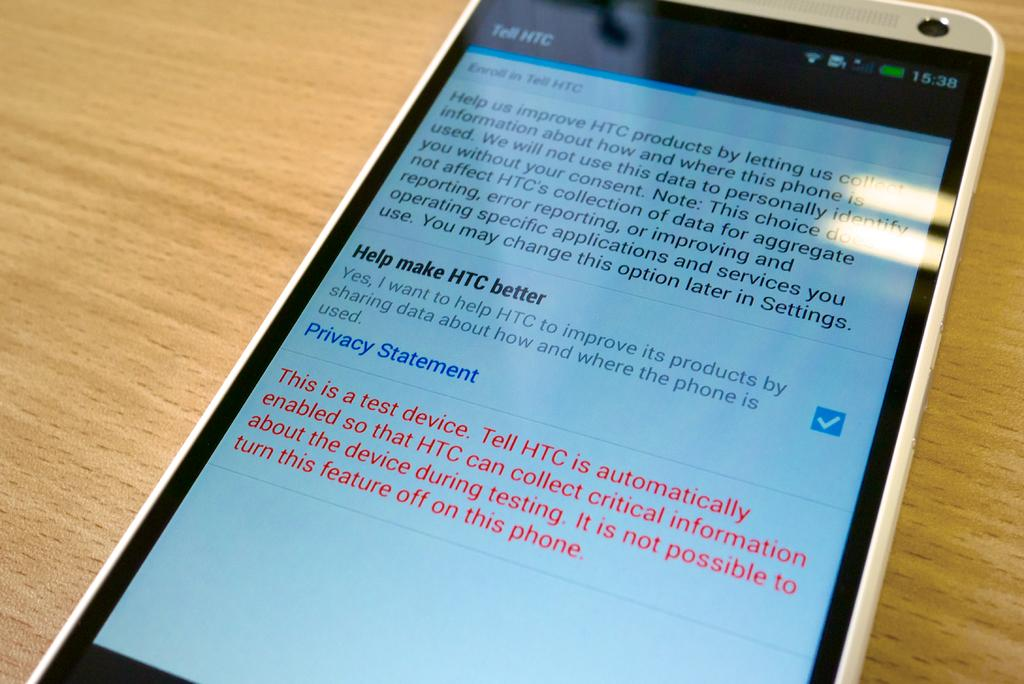<image>
Relay a brief, clear account of the picture shown. A HTC cellphone showing the screen about "Tell HTC". 